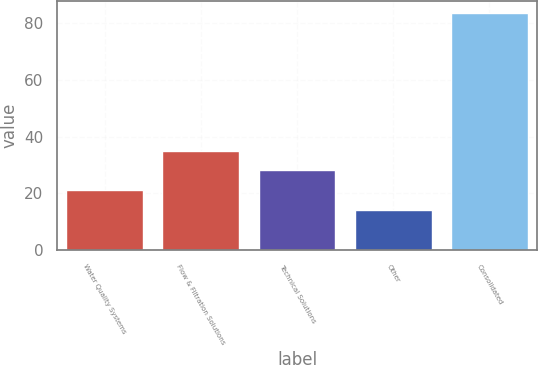Convert chart to OTSL. <chart><loc_0><loc_0><loc_500><loc_500><bar_chart><fcel>Water Quality Systems<fcel>Flow & Filtration Solutions<fcel>Technical Solutions<fcel>Other<fcel>Consolidated<nl><fcel>21.15<fcel>35.05<fcel>28.1<fcel>14.2<fcel>83.7<nl></chart> 